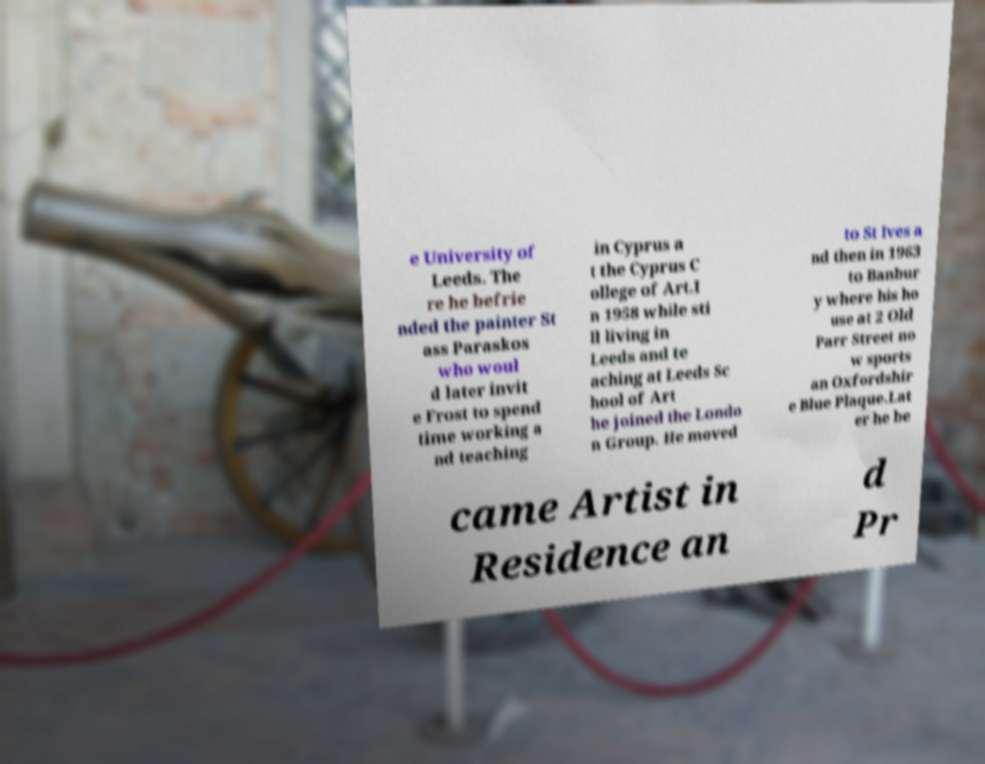Please identify and transcribe the text found in this image. e University of Leeds. The re he befrie nded the painter St ass Paraskos who woul d later invit e Frost to spend time working a nd teaching in Cyprus a t the Cyprus C ollege of Art.I n 1958 while sti ll living in Leeds and te aching at Leeds Sc hool of Art he joined the Londo n Group. He moved to St Ives a nd then in 1963 to Banbur y where his ho use at 2 Old Parr Street no w sports an Oxfordshir e Blue Plaque.Lat er he be came Artist in Residence an d Pr 